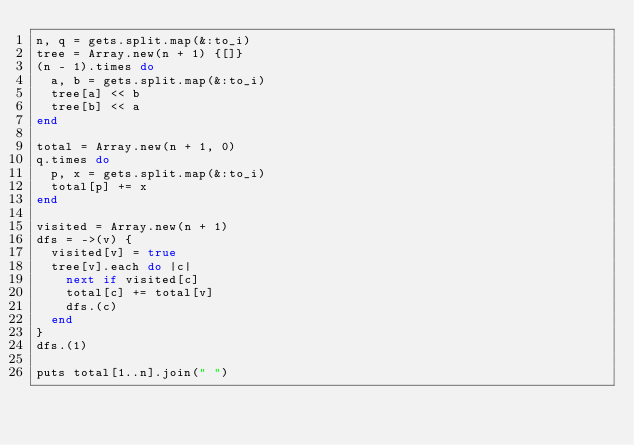<code> <loc_0><loc_0><loc_500><loc_500><_Ruby_>n, q = gets.split.map(&:to_i)
tree = Array.new(n + 1) {[]}
(n - 1).times do
  a, b = gets.split.map(&:to_i)
  tree[a] << b
  tree[b] << a
end

total = Array.new(n + 1, 0)
q.times do
  p, x = gets.split.map(&:to_i)
  total[p] += x
end

visited = Array.new(n + 1)
dfs = ->(v) {
  visited[v] = true
  tree[v].each do |c|
    next if visited[c]
    total[c] += total[v]
    dfs.(c)
  end
}
dfs.(1)

puts total[1..n].join(" ")</code> 